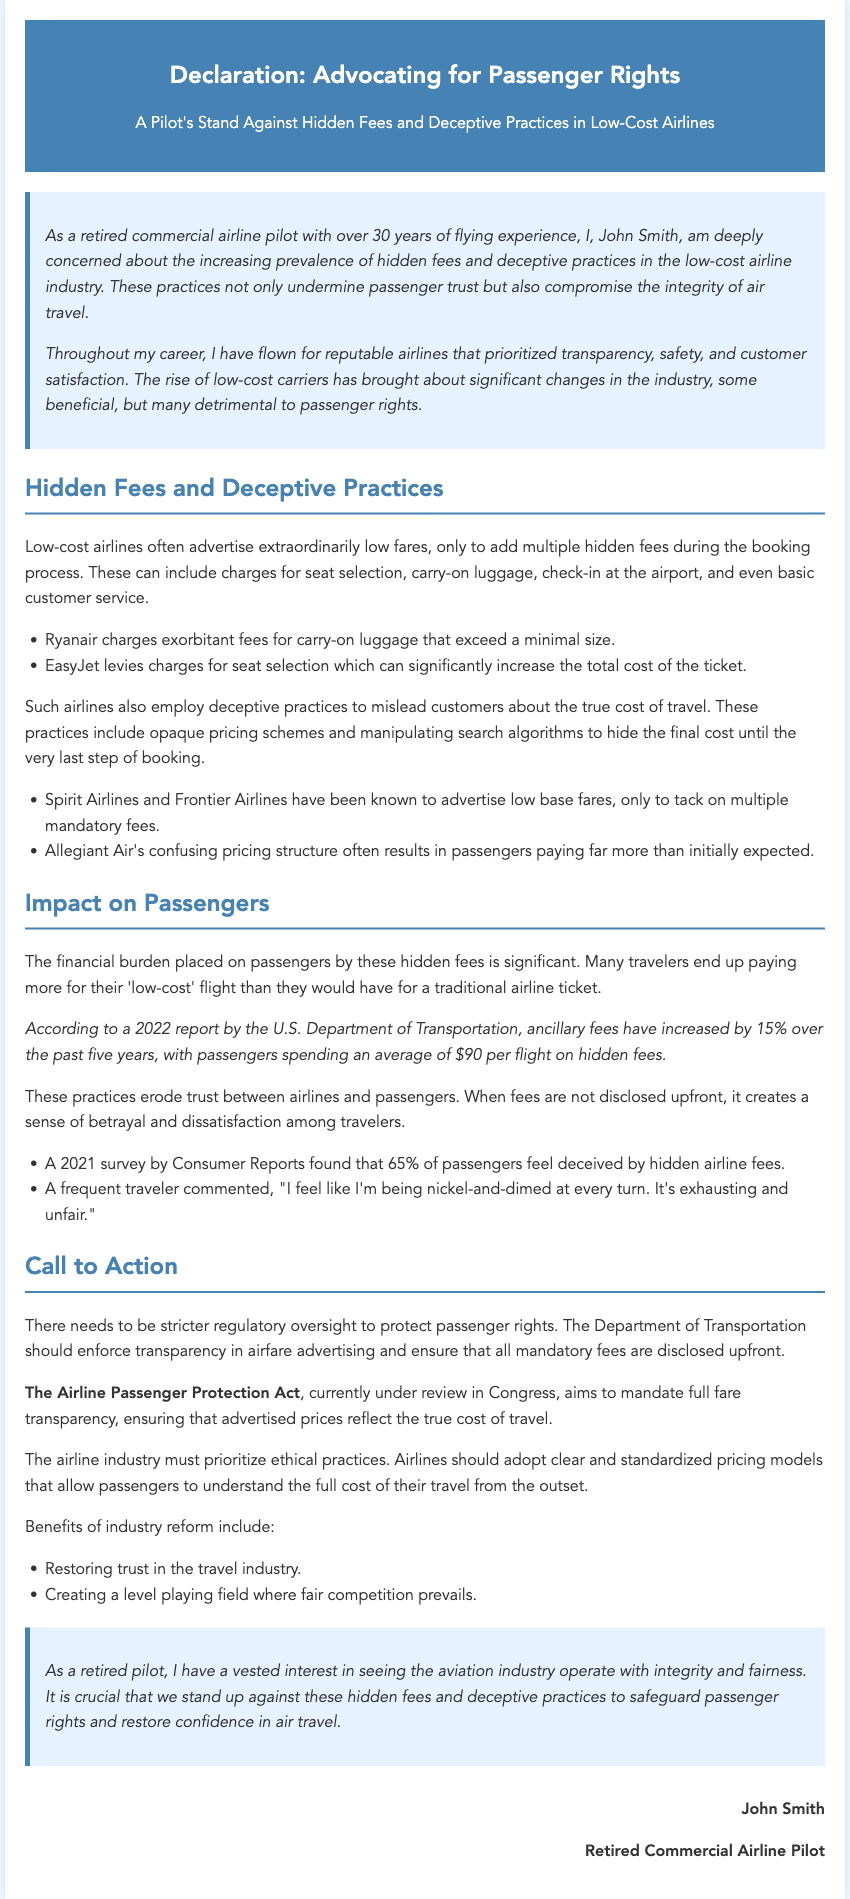What is the author's name? The document states the author's name is John Smith.
Answer: John Smith What is the main concern expressed in the declaration? The declaration highlights hidden fees and deceptive practices in the low-cost airline industry as the main concern.
Answer: Hidden fees and deceptive practices What percentage of passengers feel deceived by hidden airline fees? According to a 2021 survey by Consumer Reports mentioned in the document, 65% of passengers feel deceived by hidden airline fees.
Answer: 65% What is the average amount passengers spend on hidden fees per flight? The document states that passengers spend an average of $90 per flight on hidden fees.
Answer: $90 What is the title of the proposed legislation mentioned? The proposed legislation aimed at protecting passenger rights is called the Airline Passenger Protection Act.
Answer: Airline Passenger Protection Act What does the author suggest should be enforced by the Department of Transportation? The author suggests enforcing transparency in airfare advertising and mandatory fee disclosure.
Answer: Transparency in airfare advertising What was the increase percentage of ancillary fees over the past five years? The document states that ancillary fees have increased by 15% over the past five years.
Answer: 15% Who authored this declaration? The declaration is authored by a retired commercial airline pilot.
Answer: Retired commercial airline pilot What is one proposed benefit of industry reform? The document mentions restoring trust in the travel industry as a proposed benefit of industry reform.
Answer: Restoring trust in the travel industry 